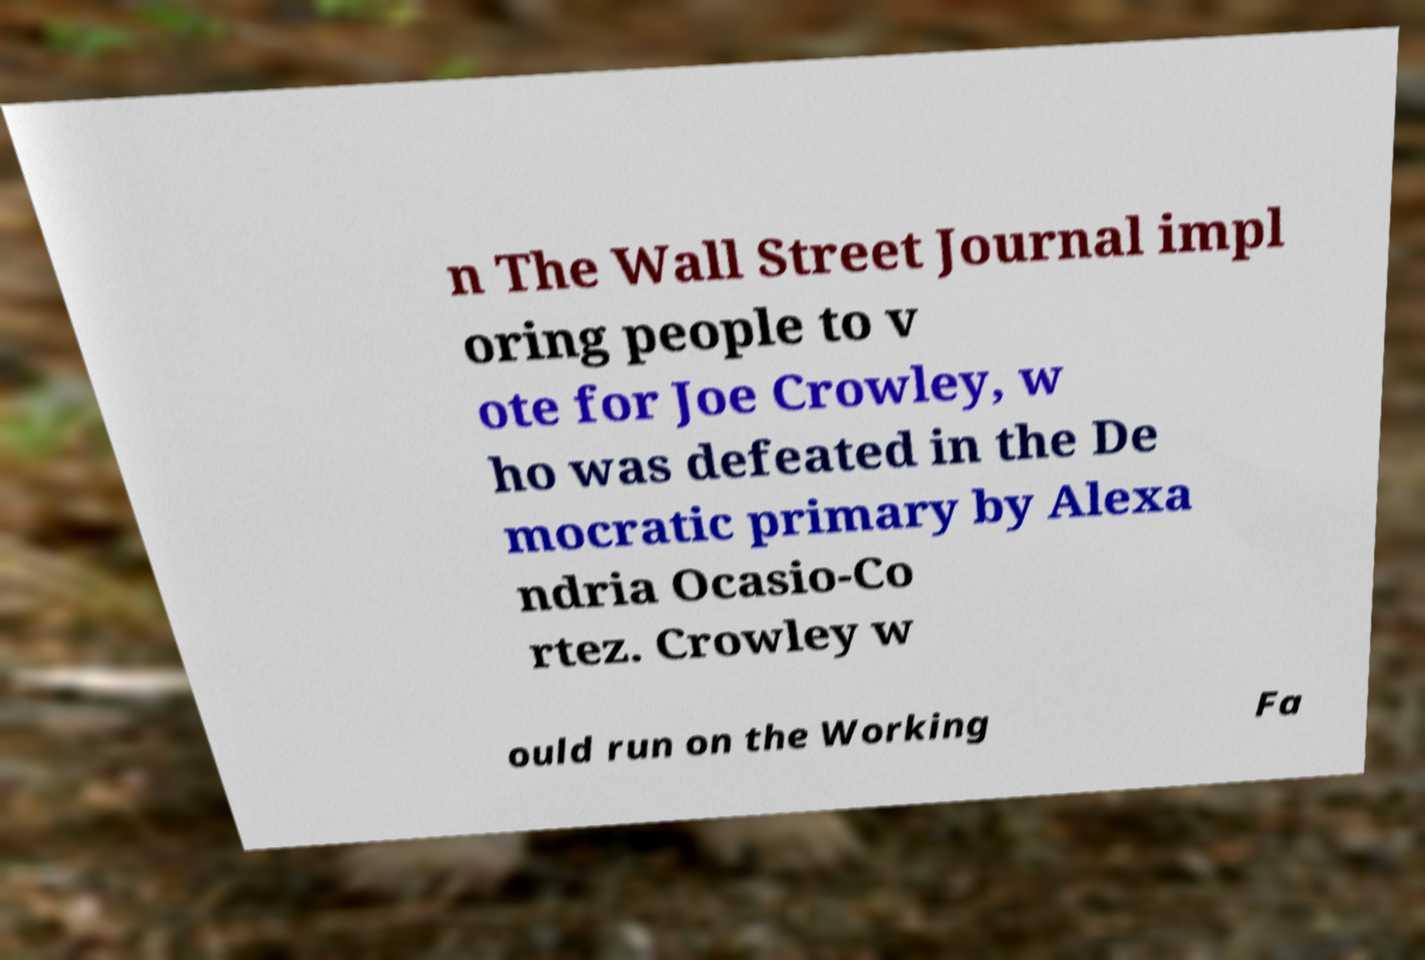Could you extract and type out the text from this image? n The Wall Street Journal impl oring people to v ote for Joe Crowley, w ho was defeated in the De mocratic primary by Alexa ndria Ocasio-Co rtez. Crowley w ould run on the Working Fa 